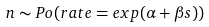Convert formula to latex. <formula><loc_0><loc_0><loc_500><loc_500>n \sim P o ( r a t e = e x p ( \alpha + \beta s ) )</formula> 